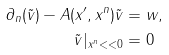Convert formula to latex. <formula><loc_0><loc_0><loc_500><loc_500>\partial _ { n } ( \tilde { v } ) - A ( x ^ { \prime } , x ^ { n } ) \tilde { v } & = w , \\ \tilde { v } | _ { x ^ { n } < < 0 } & = 0</formula> 